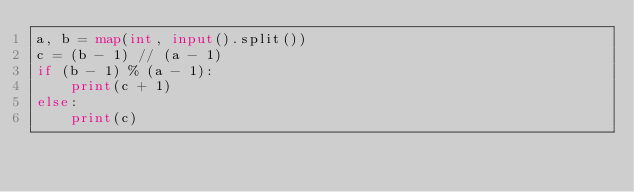<code> <loc_0><loc_0><loc_500><loc_500><_Python_>a, b = map(int, input().split())
c = (b - 1) // (a - 1)
if (b - 1) % (a - 1):
    print(c + 1)
else:
    print(c)</code> 